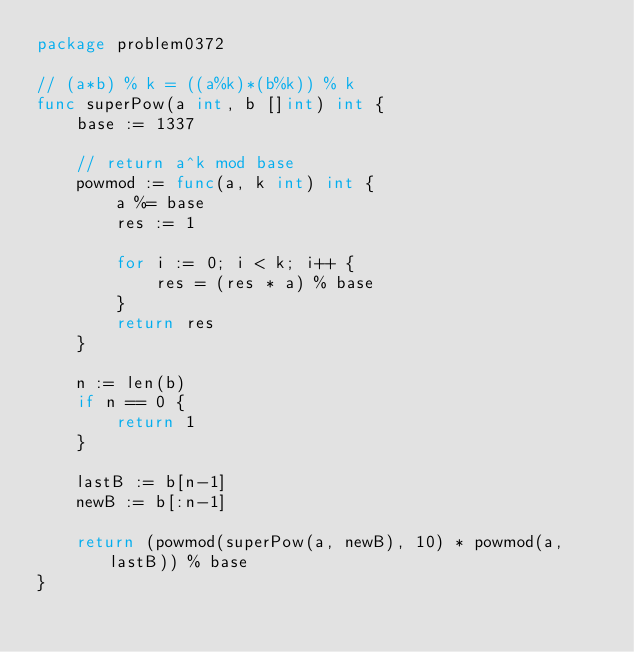Convert code to text. <code><loc_0><loc_0><loc_500><loc_500><_Go_>package problem0372

// (a*b) % k = ((a%k)*(b%k)) % k
func superPow(a int, b []int) int {
	base := 1337

	// return a^k mod base
	powmod := func(a, k int) int {
		a %= base
		res := 1

		for i := 0; i < k; i++ {
			res = (res * a) % base
		}
		return res
	}

	n := len(b)
	if n == 0 {
		return 1
	}

	lastB := b[n-1]
	newB := b[:n-1]

	return (powmod(superPow(a, newB), 10) * powmod(a, lastB)) % base
}
</code> 